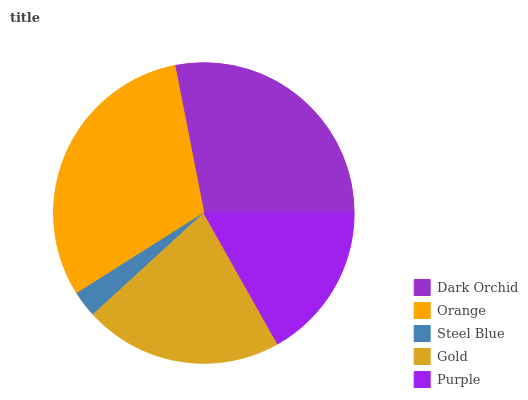Is Steel Blue the minimum?
Answer yes or no. Yes. Is Orange the maximum?
Answer yes or no. Yes. Is Orange the minimum?
Answer yes or no. No. Is Steel Blue the maximum?
Answer yes or no. No. Is Orange greater than Steel Blue?
Answer yes or no. Yes. Is Steel Blue less than Orange?
Answer yes or no. Yes. Is Steel Blue greater than Orange?
Answer yes or no. No. Is Orange less than Steel Blue?
Answer yes or no. No. Is Gold the high median?
Answer yes or no. Yes. Is Gold the low median?
Answer yes or no. Yes. Is Dark Orchid the high median?
Answer yes or no. No. Is Dark Orchid the low median?
Answer yes or no. No. 